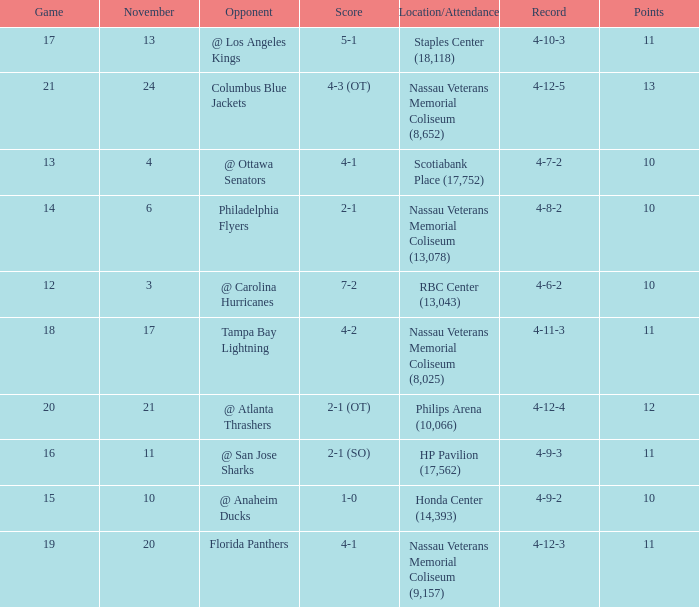What is every game on November 21? 20.0. 